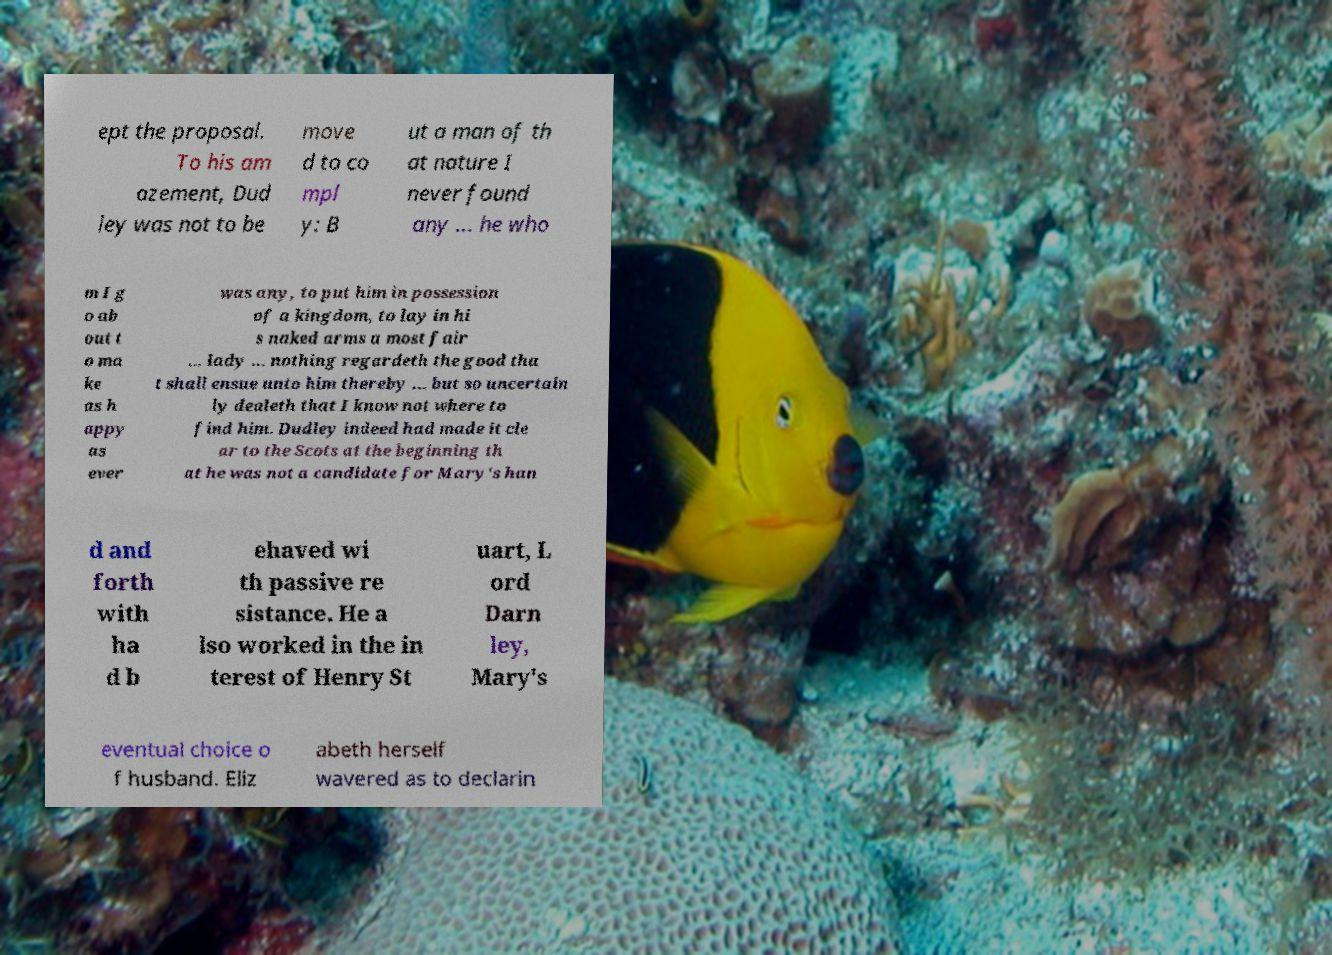For documentation purposes, I need the text within this image transcribed. Could you provide that? ept the proposal. To his am azement, Dud ley was not to be move d to co mpl y: B ut a man of th at nature I never found any ... he who m I g o ab out t o ma ke as h appy as ever was any, to put him in possession of a kingdom, to lay in hi s naked arms a most fair ... lady ... nothing regardeth the good tha t shall ensue unto him thereby ... but so uncertain ly dealeth that I know not where to find him. Dudley indeed had made it cle ar to the Scots at the beginning th at he was not a candidate for Mary's han d and forth with ha d b ehaved wi th passive re sistance. He a lso worked in the in terest of Henry St uart, L ord Darn ley, Mary's eventual choice o f husband. Eliz abeth herself wavered as to declarin 